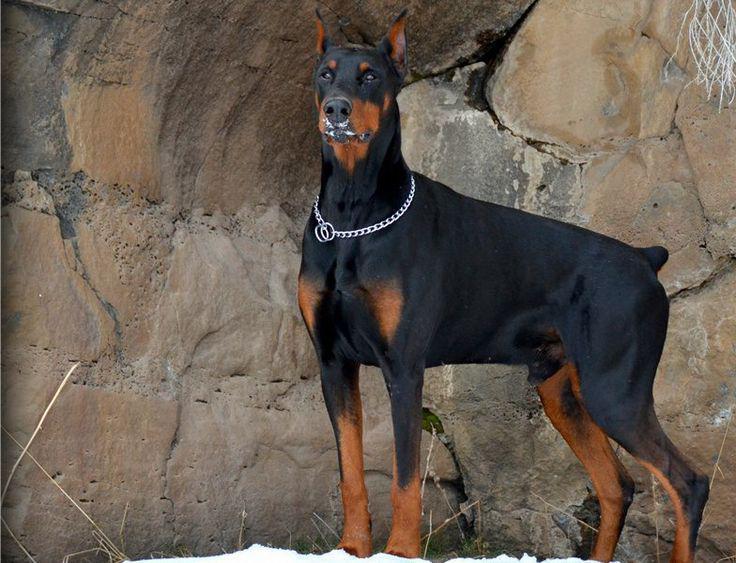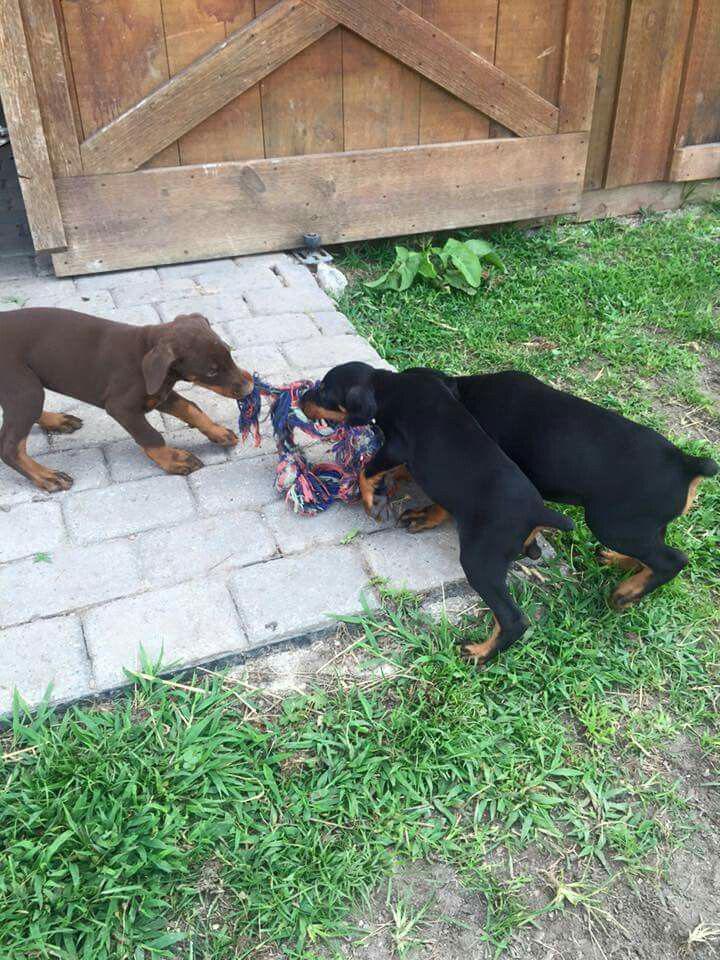The first image is the image on the left, the second image is the image on the right. For the images shown, is this caption "Two dogs are laying in grass." true? Answer yes or no. No. The first image is the image on the left, the second image is the image on the right. Assess this claim about the two images: "The right image features one doberman with its front paws forward on the ground and its mouth on a pale object on the grass.". Correct or not? Answer yes or no. No. 